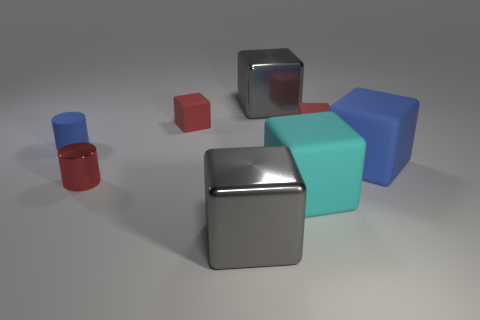Subtract 2 cubes. How many cubes are left? 4 Subtract all big rubber cubes. How many cubes are left? 4 Subtract all blue cubes. How many cubes are left? 5 Subtract all purple blocks. Subtract all gray balls. How many blocks are left? 6 Add 1 large gray cylinders. How many objects exist? 9 Subtract all cylinders. How many objects are left? 6 Add 7 big blue metallic cylinders. How many big blue metallic cylinders exist? 7 Subtract 1 cyan blocks. How many objects are left? 7 Subtract all shiny objects. Subtract all small matte things. How many objects are left? 2 Add 3 large gray blocks. How many large gray blocks are left? 5 